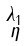<formula> <loc_0><loc_0><loc_500><loc_500>\begin{smallmatrix} \lambda _ { 1 } \\ \eta \end{smallmatrix}</formula> 